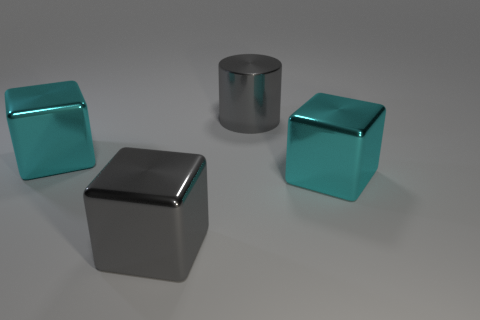There is a gray metallic cube; does it have the same size as the cyan metal block right of the cylinder?
Your response must be concise. Yes. How many balls are shiny objects or big cyan things?
Provide a succinct answer. 0. How many big gray things are on the right side of the gray cube and in front of the big metal cylinder?
Ensure brevity in your answer.  0. What number of other objects are there of the same color as the cylinder?
Provide a short and direct response. 1. What shape is the big gray thing that is right of the big gray metal cube?
Your response must be concise. Cylinder. Does the gray block have the same material as the big cylinder?
Your response must be concise. Yes. What number of large cyan cubes are left of the large gray metallic block?
Offer a terse response. 1. The large cyan metal thing that is on the right side of the gray metallic object that is on the left side of the big cylinder is what shape?
Your answer should be very brief. Cube. Are there more big things that are on the right side of the big gray metal cylinder than small cyan shiny objects?
Provide a succinct answer. Yes. What number of big objects are in front of the metallic cylinder that is behind the gray cube?
Give a very brief answer. 3. 